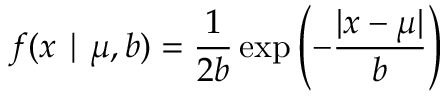Convert formula to latex. <formula><loc_0><loc_0><loc_500><loc_500>f ( x | \mu , b ) = { \frac { 1 } { 2 b } } \exp \left ( - { \frac { | x - \mu | } { b } } \right ) \,</formula> 